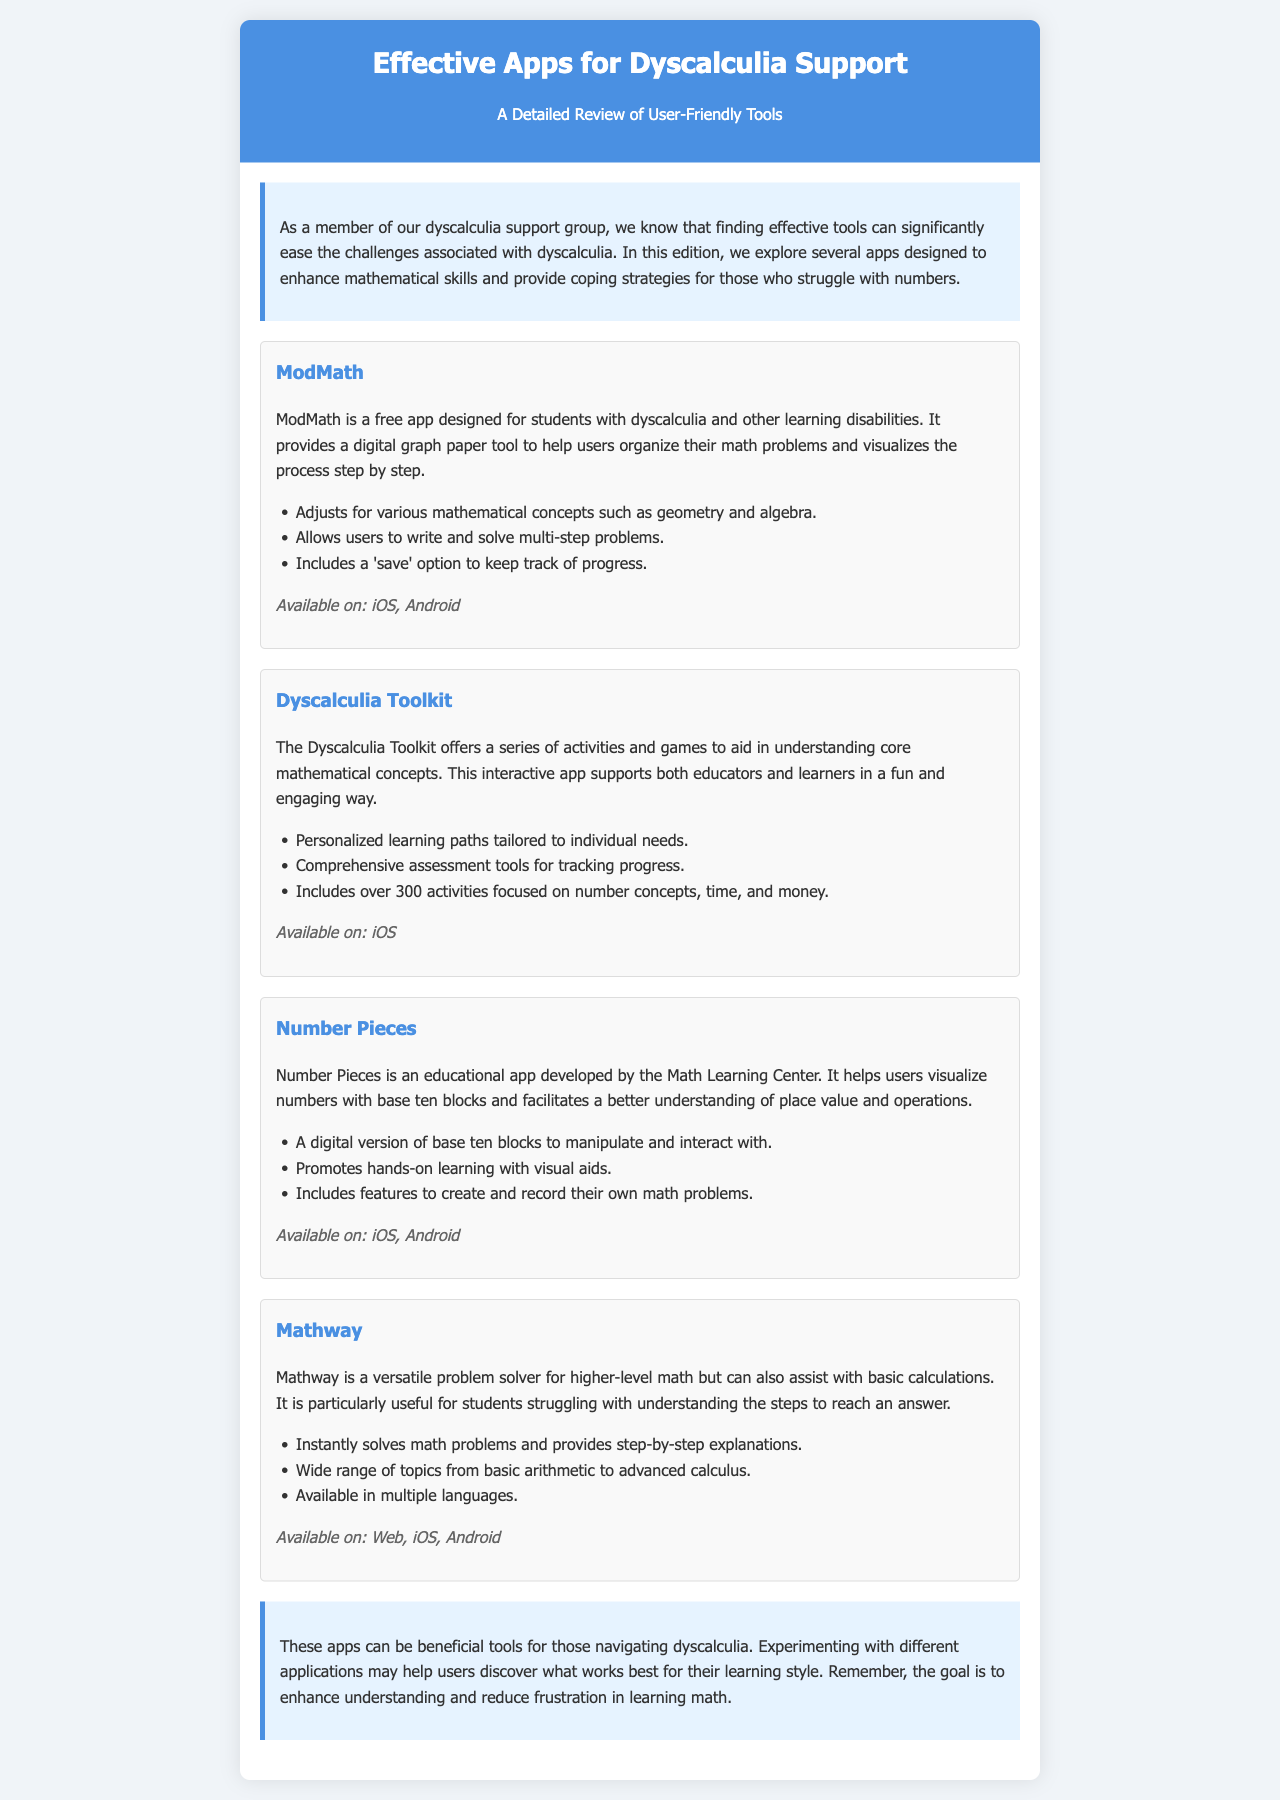what is the title of the newsletter? The title of the newsletter is prominently displayed at the top of the document.
Answer: Effective Apps for Dyscalculia Support how many apps are reviewed in the newsletter? The document lists four distinct apps designed for dyscalculia support.
Answer: Four which app is designed for higher-level math and basic calculations? The app that addresses both higher-level math and basic calculations is specified in the document.
Answer: Mathway what platforms is ModMath available on? The platforms for ModMath are explicitly mentioned in the document.
Answer: iOS, Android what type of learning paths does the Dyscalculia Toolkit offer? The document describes the tailoring of learning paths found in the Dyscalculia Toolkit.
Answer: Personalized learning paths how does Number Pieces assist users in understanding math? Number Pieces aids users with specific educational tools and methods described in the document.
Answer: Visualize numbers with base ten blocks what is the purpose of the intro section in the newsletter? The intro section outlines the document's intention and relevance to the target audience.
Answer: To ease challenges associated with dyscalculia what is a unique feature of Mathway described in the document? Unique features of Mathway are detailed within its description in the document.
Answer: Step-by-step explanations 